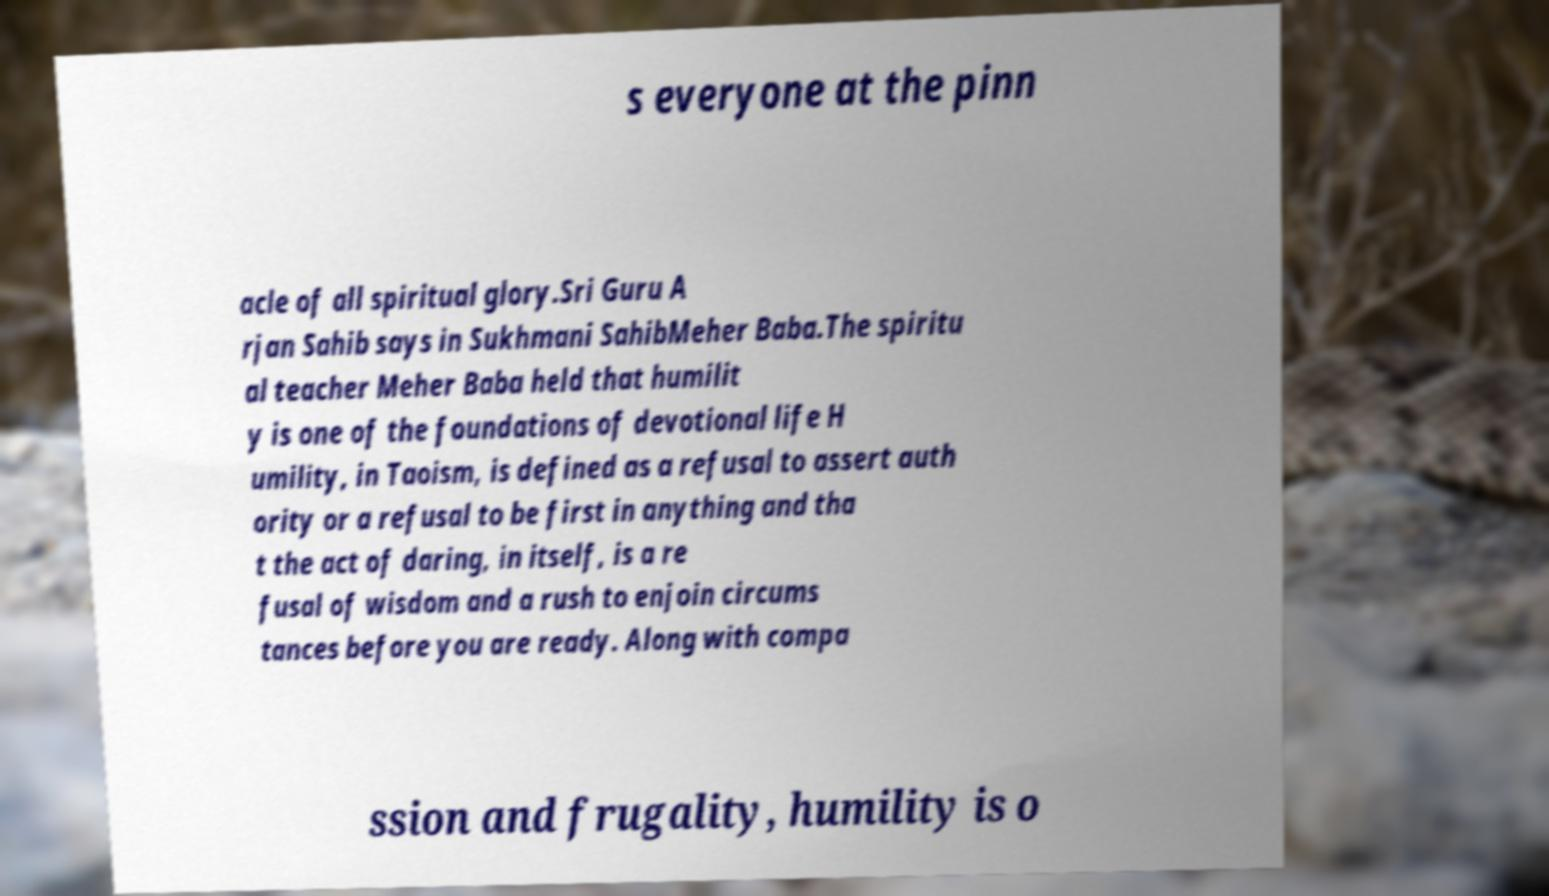I need the written content from this picture converted into text. Can you do that? s everyone at the pinn acle of all spiritual glory.Sri Guru A rjan Sahib says in Sukhmani SahibMeher Baba.The spiritu al teacher Meher Baba held that humilit y is one of the foundations of devotional life H umility, in Taoism, is defined as a refusal to assert auth ority or a refusal to be first in anything and tha t the act of daring, in itself, is a re fusal of wisdom and a rush to enjoin circums tances before you are ready. Along with compa ssion and frugality, humility is o 